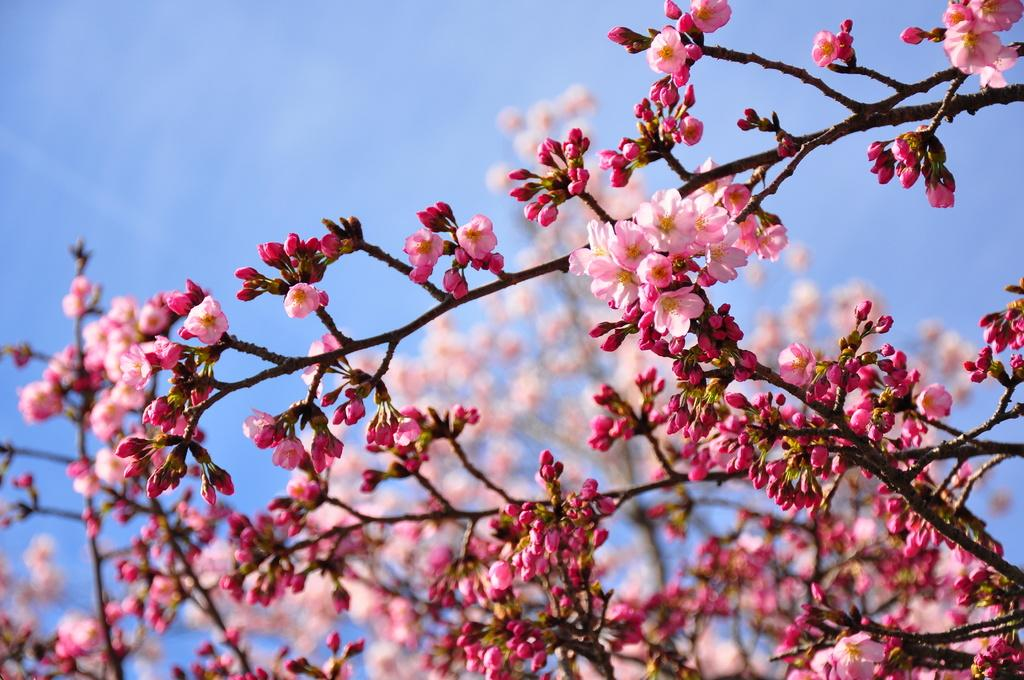What type of plant can be seen in the image? There is a tree in the image. Are there any other flora visible in the image? Yes, there are flowers in the image. How would you describe the background of the image? The background of the image is blurred. What part of the natural environment can be seen in the image? The sky is visible in the background of the image. How many deer can be seen in the image? There are no deer present in the image. What type of weather condition is depicted by the fog in the image? There is no fog present in the image. 